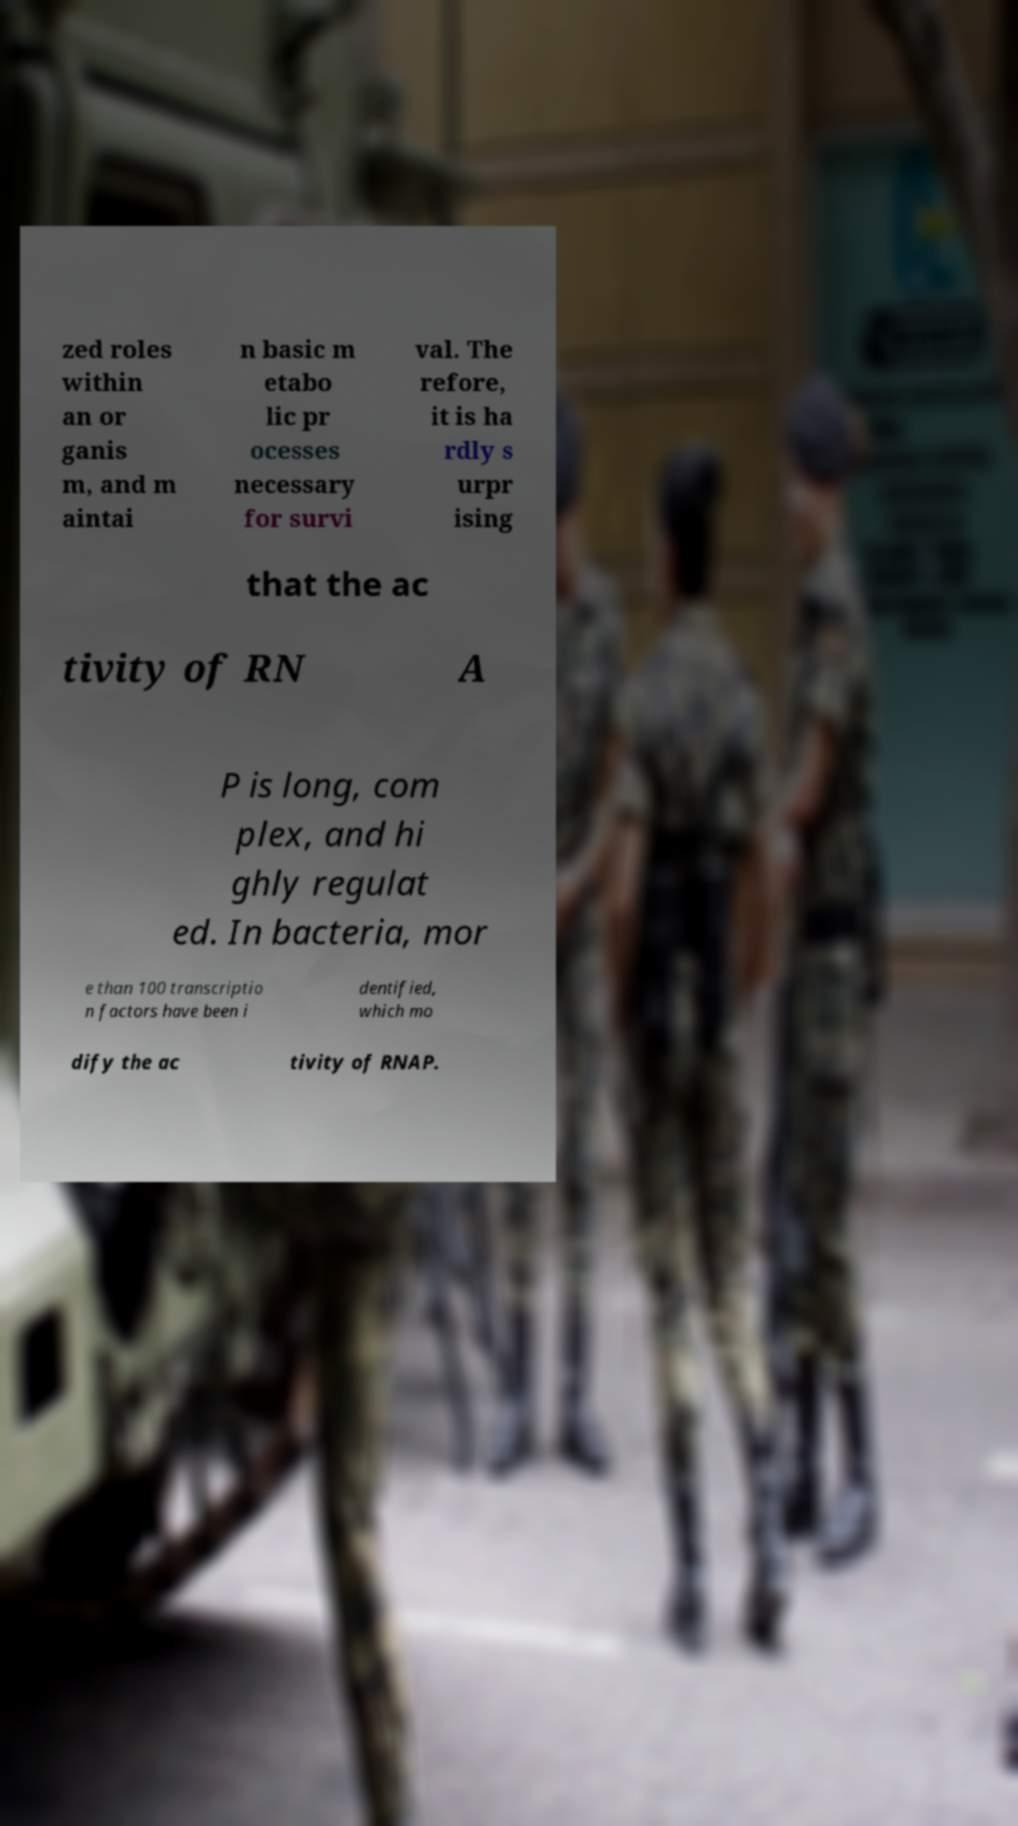There's text embedded in this image that I need extracted. Can you transcribe it verbatim? zed roles within an or ganis m, and m aintai n basic m etabo lic pr ocesses necessary for survi val. The refore, it is ha rdly s urpr ising that the ac tivity of RN A P is long, com plex, and hi ghly regulat ed. In bacteria, mor e than 100 transcriptio n factors have been i dentified, which mo dify the ac tivity of RNAP. 